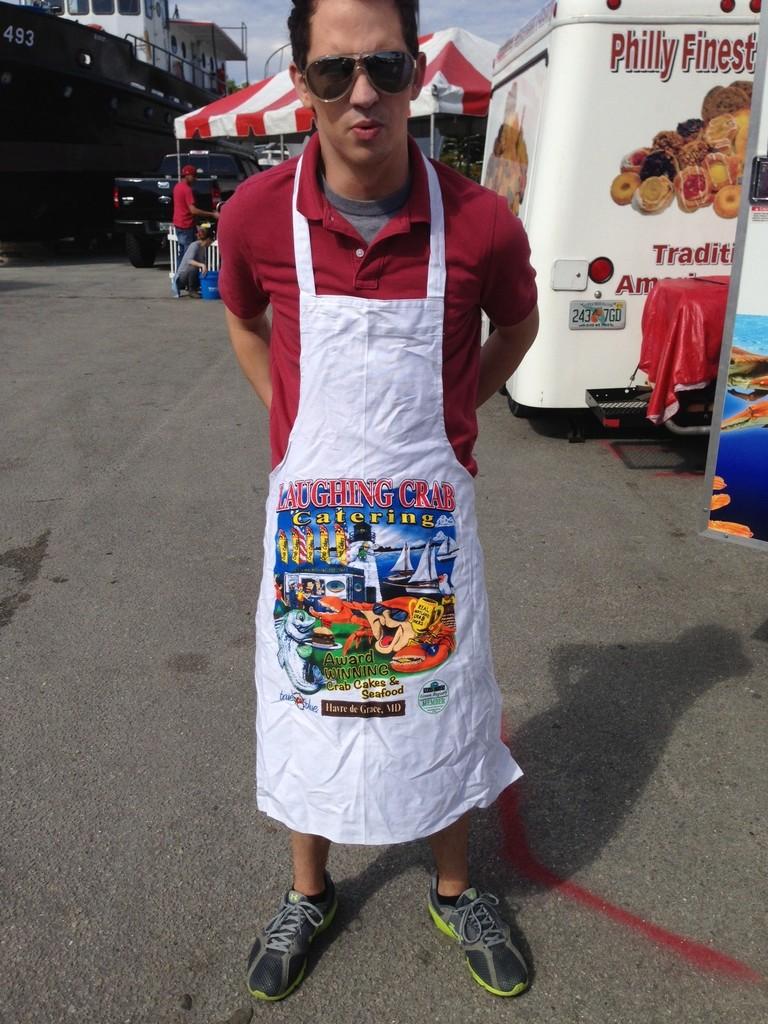What is on your apron?
Your answer should be compact. Unanswerable. 